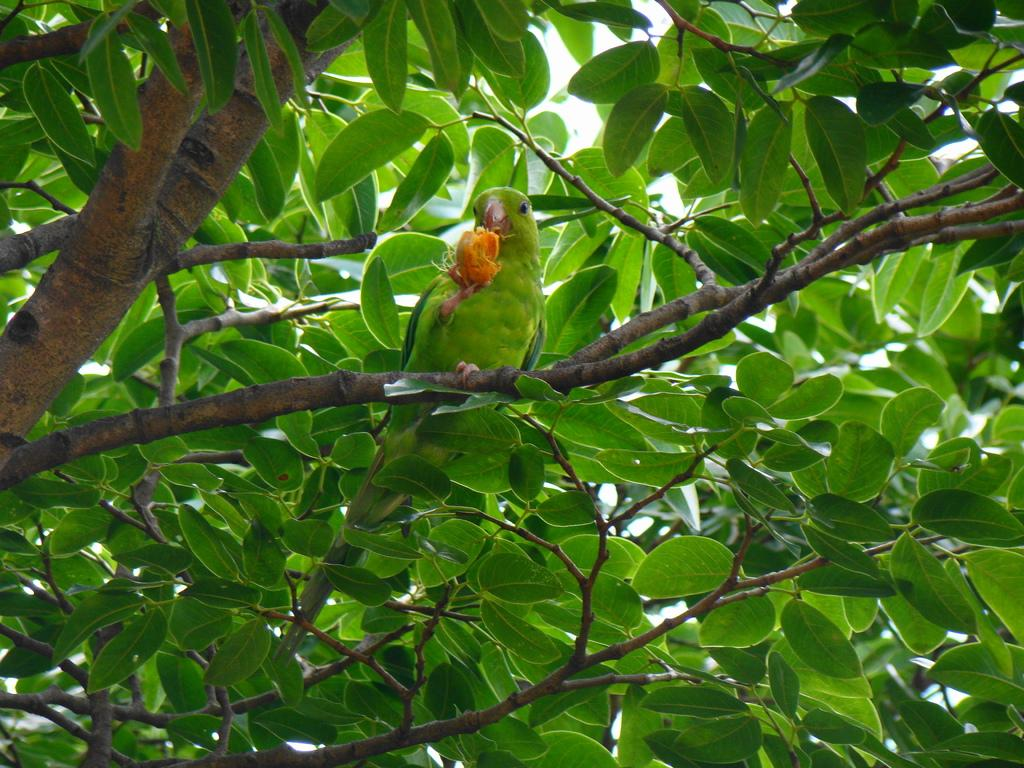What type of animal is in the image? There is a parrot in the image. Where is the parrot located in the image? The parrot is standing on a stem. What is the parrot holding in the image? The parrot is holding an object. What can be seen in the background of the image? There are leaves visible in the image. How many spiders are crawling on the parrot in the image? There are no spiders visible in the image; it only features a parrot standing on a stem and holding an object. What type of knowledge does the parrot possess in the image? The image does not provide any information about the parrot's knowledge or intelligence. 